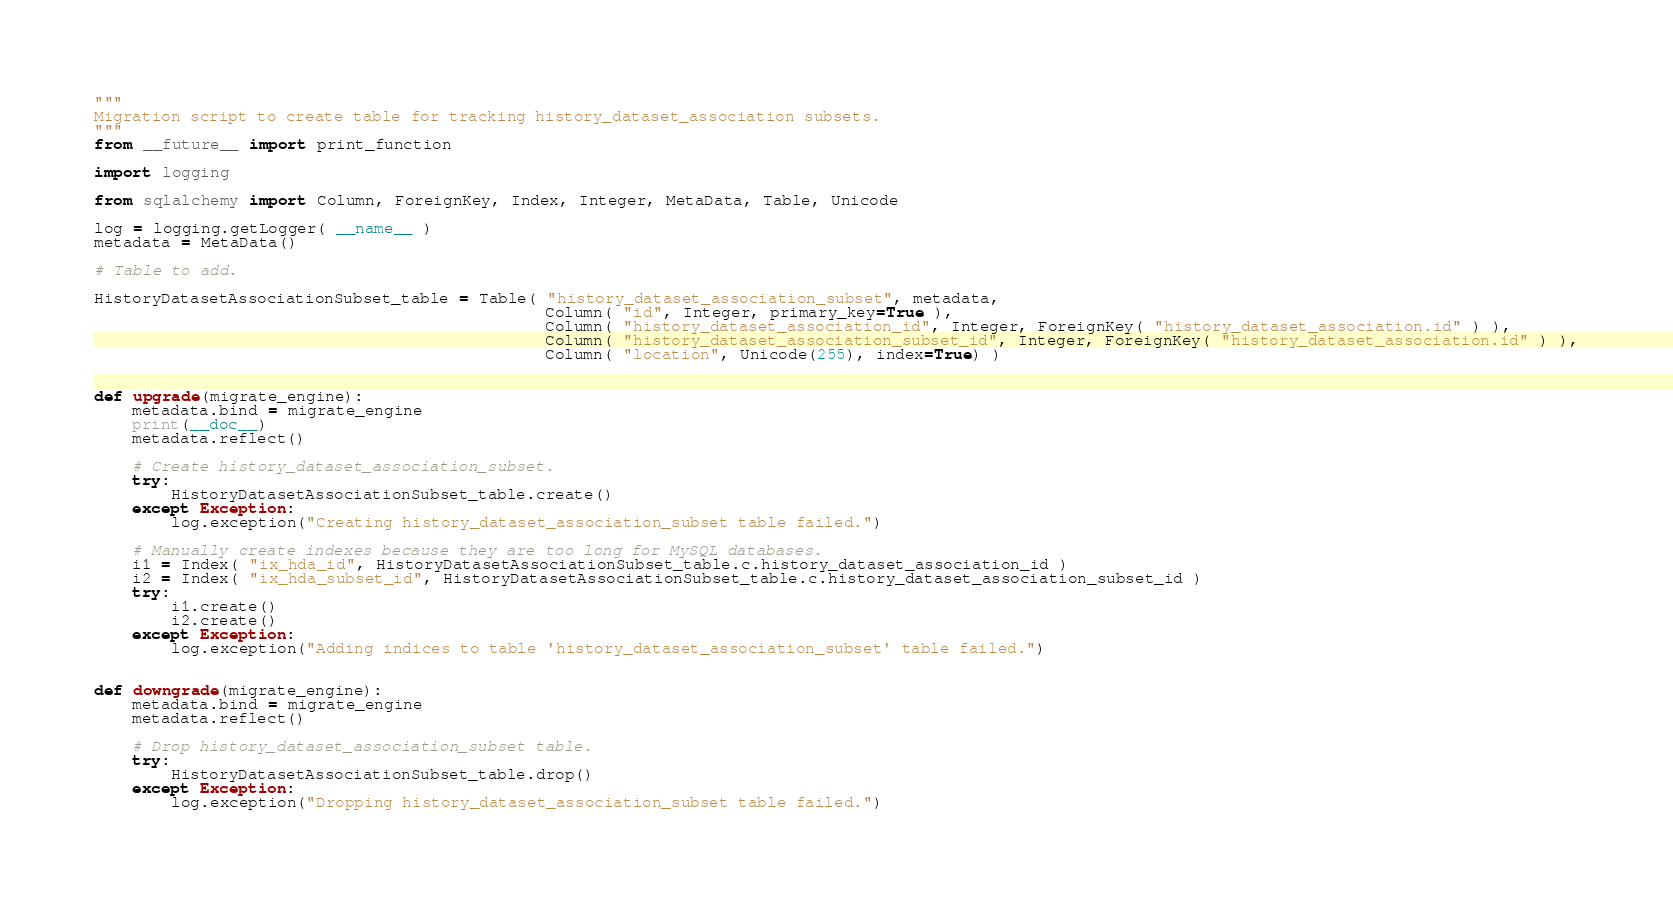<code> <loc_0><loc_0><loc_500><loc_500><_Python_>"""
Migration script to create table for tracking history_dataset_association subsets.
"""
from __future__ import print_function

import logging

from sqlalchemy import Column, ForeignKey, Index, Integer, MetaData, Table, Unicode

log = logging.getLogger( __name__ )
metadata = MetaData()

# Table to add.

HistoryDatasetAssociationSubset_table = Table( "history_dataset_association_subset", metadata,
                                               Column( "id", Integer, primary_key=True ),
                                               Column( "history_dataset_association_id", Integer, ForeignKey( "history_dataset_association.id" ) ),
                                               Column( "history_dataset_association_subset_id", Integer, ForeignKey( "history_dataset_association.id" ) ),
                                               Column( "location", Unicode(255), index=True) )


def upgrade(migrate_engine):
    metadata.bind = migrate_engine
    print(__doc__)
    metadata.reflect()

    # Create history_dataset_association_subset.
    try:
        HistoryDatasetAssociationSubset_table.create()
    except Exception:
        log.exception("Creating history_dataset_association_subset table failed.")

    # Manually create indexes because they are too long for MySQL databases.
    i1 = Index( "ix_hda_id", HistoryDatasetAssociationSubset_table.c.history_dataset_association_id )
    i2 = Index( "ix_hda_subset_id", HistoryDatasetAssociationSubset_table.c.history_dataset_association_subset_id )
    try:
        i1.create()
        i2.create()
    except Exception:
        log.exception("Adding indices to table 'history_dataset_association_subset' table failed.")


def downgrade(migrate_engine):
    metadata.bind = migrate_engine
    metadata.reflect()

    # Drop history_dataset_association_subset table.
    try:
        HistoryDatasetAssociationSubset_table.drop()
    except Exception:
        log.exception("Dropping history_dataset_association_subset table failed.")
</code> 